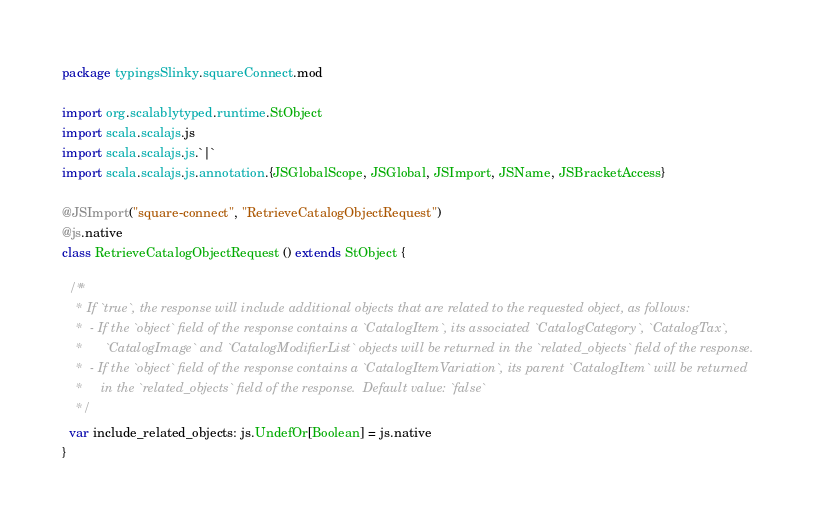<code> <loc_0><loc_0><loc_500><loc_500><_Scala_>package typingsSlinky.squareConnect.mod

import org.scalablytyped.runtime.StObject
import scala.scalajs.js
import scala.scalajs.js.`|`
import scala.scalajs.js.annotation.{JSGlobalScope, JSGlobal, JSImport, JSName, JSBracketAccess}

@JSImport("square-connect", "RetrieveCatalogObjectRequest")
@js.native
class RetrieveCatalogObjectRequest () extends StObject {
  
  /**
    * If `true`, the response will include additional objects that are related to the requested object, as follows:
    *  - If the `object` field of the response contains a `CatalogItem`, its associated `CatalogCategory`, `CatalogTax`,
    *      `CatalogImage` and `CatalogModifierList` objects will be returned in the `related_objects` field of the response.
    *  - If the `object` field of the response contains a `CatalogItemVariation`, its parent `CatalogItem` will be returned
    *     in the `related_objects` field of the response.  Default value: `false`
    */
  var include_related_objects: js.UndefOr[Boolean] = js.native
}
</code> 